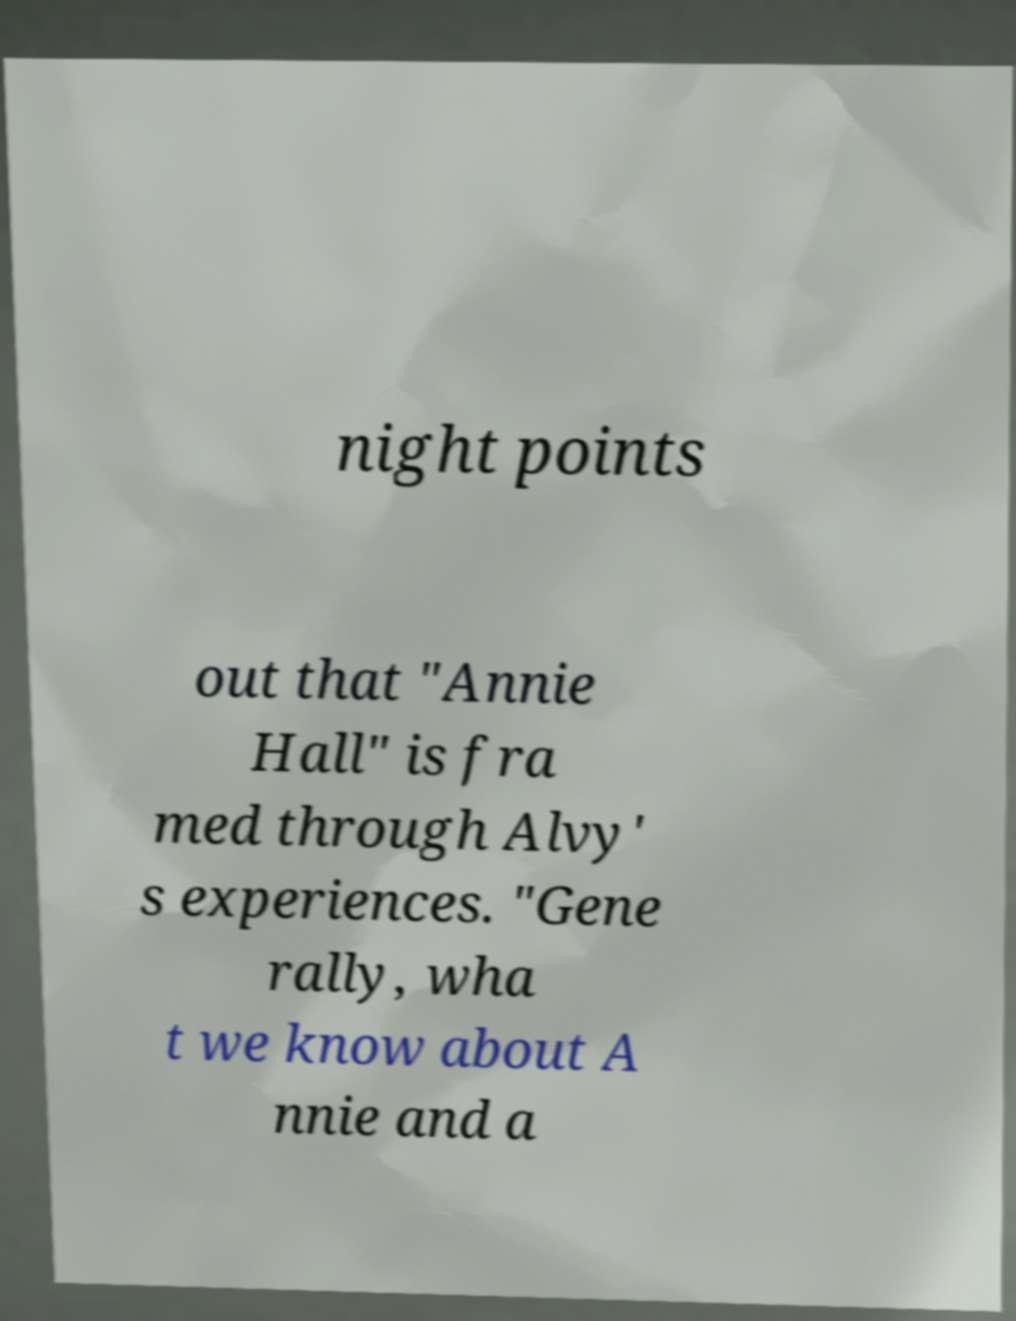What messages or text are displayed in this image? I need them in a readable, typed format. night points out that "Annie Hall" is fra med through Alvy' s experiences. "Gene rally, wha t we know about A nnie and a 